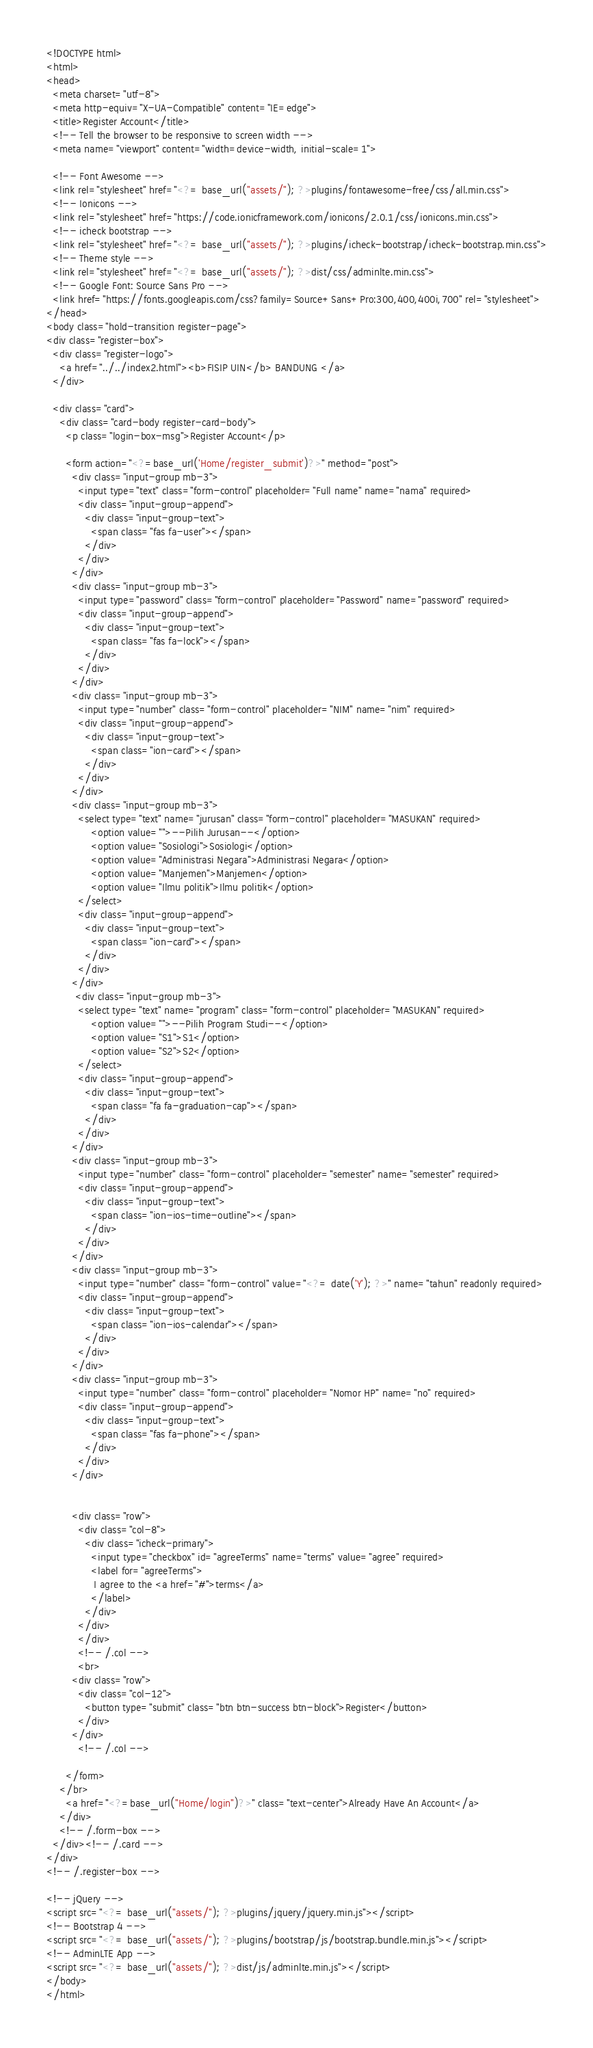<code> <loc_0><loc_0><loc_500><loc_500><_PHP_><!DOCTYPE html>
<html>
<head>
  <meta charset="utf-8">
  <meta http-equiv="X-UA-Compatible" content="IE=edge">
  <title>Register Account</title>
  <!-- Tell the browser to be responsive to screen width -->
  <meta name="viewport" content="width=device-width, initial-scale=1">

  <!-- Font Awesome -->
  <link rel="stylesheet" href="<?= base_url("assets/"); ?>plugins/fontawesome-free/css/all.min.css">
  <!-- Ionicons -->
  <link rel="stylesheet" href="https://code.ionicframework.com/ionicons/2.0.1/css/ionicons.min.css">
  <!-- icheck bootstrap -->
  <link rel="stylesheet" href="<?= base_url("assets/"); ?>plugins/icheck-bootstrap/icheck-bootstrap.min.css">
  <!-- Theme style -->
  <link rel="stylesheet" href="<?= base_url("assets/"); ?>dist/css/adminlte.min.css">
  <!-- Google Font: Source Sans Pro -->
  <link href="https://fonts.googleapis.com/css?family=Source+Sans+Pro:300,400,400i,700" rel="stylesheet">
</head>
<body class="hold-transition register-page">
<div class="register-box">
  <div class="register-logo">
    <a href="../../index2.html"><b>FISIP UIN</b> BANDUNG </a>
  </div>

  <div class="card">
    <div class="card-body register-card-body">
      <p class="login-box-msg">Register Account</p>

      <form action="<?=base_url('Home/register_submit')?>" method="post">
        <div class="input-group mb-3">
          <input type="text" class="form-control" placeholder="Full name" name="nama" required>
          <div class="input-group-append">
            <div class="input-group-text">
              <span class="fas fa-user"></span>
            </div>
          </div>
        </div>
        <div class="input-group mb-3">
          <input type="password" class="form-control" placeholder="Password" name="password" required>
          <div class="input-group-append">
            <div class="input-group-text">
              <span class="fas fa-lock"></span>
            </div>
          </div>
        </div>
        <div class="input-group mb-3">
          <input type="number" class="form-control" placeholder="NIM" name="nim" required>
          <div class="input-group-append">
            <div class="input-group-text">
              <span class="ion-card"></span>
            </div>
          </div>
        </div>
        <div class="input-group mb-3">
          <select type="text" name="jurusan" class="form-control" placeholder="MASUKAN" required>
              <option value="">--Pilih Jurusan--</option>
              <option value="Sosiologi">Sosiologi</option>
              <option value="Administrasi Negara">Administrasi Negara</option>
              <option value="Manjemen">Manjemen</option>
              <option value="Ilmu politik">Ilmu politik</option>
          </select>
          <div class="input-group-append">
            <div class="input-group-text">
              <span class="ion-card"></span>
            </div>
          </div>
        </div>
         <div class="input-group mb-3">
          <select type="text" name="program" class="form-control" placeholder="MASUKAN" required>
              <option value="">--Pilih Program Studi--</option>
              <option value="S1">S1</option>
              <option value="S2">S2</option>
          </select>
          <div class="input-group-append">
            <div class="input-group-text">
              <span class="fa fa-graduation-cap"></span>
            </div>
          </div>
        </div>
        <div class="input-group mb-3">
          <input type="number" class="form-control" placeholder="semester" name="semester" required>
          <div class="input-group-append">
            <div class="input-group-text">
              <span class="ion-ios-time-outline"></span>
            </div>
          </div>
        </div>
        <div class="input-group mb-3">
          <input type="number" class="form-control" value="<?= date('Y'); ?>" name="tahun" readonly required>
          <div class="input-group-append">
            <div class="input-group-text">
              <span class="ion-ios-calendar"></span>
            </div>
          </div>
        </div>
        <div class="input-group mb-3">
          <input type="number" class="form-control" placeholder="Nomor HP" name="no" required>
          <div class="input-group-append">
            <div class="input-group-text">
              <span class="fas fa-phone"></span>
            </div>
          </div>
        </div>


        <div class="row">
          <div class="col-8">
            <div class="icheck-primary">
              <input type="checkbox" id="agreeTerms" name="terms" value="agree" required>
              <label for="agreeTerms">
               I agree to the <a href="#">terms</a>
              </label>
            </div>
          </div>
          </div>
          <!-- /.col -->
          <br>
        <div class="row">
          <div class="col-12">
            <button type="submit" class="btn btn-success btn-block">Register</button>
          </div>
        </div>
          <!-- /.col -->
        
      </form>
    </br>
      <a href="<?=base_url("Home/login")?>" class="text-center">Already Have An Account</a>
    </div>
    <!-- /.form-box -->
  </div><!-- /.card -->
</div>
<!-- /.register-box -->

<!-- jQuery -->
<script src="<?= base_url("assets/"); ?>plugins/jquery/jquery.min.js"></script>
<!-- Bootstrap 4 -->
<script src="<?= base_url("assets/"); ?>plugins/bootstrap/js/bootstrap.bundle.min.js"></script>
<!-- AdminLTE App -->
<script src="<?= base_url("assets/"); ?>dist/js/adminlte.min.js"></script>
</body>
</html>
</code> 